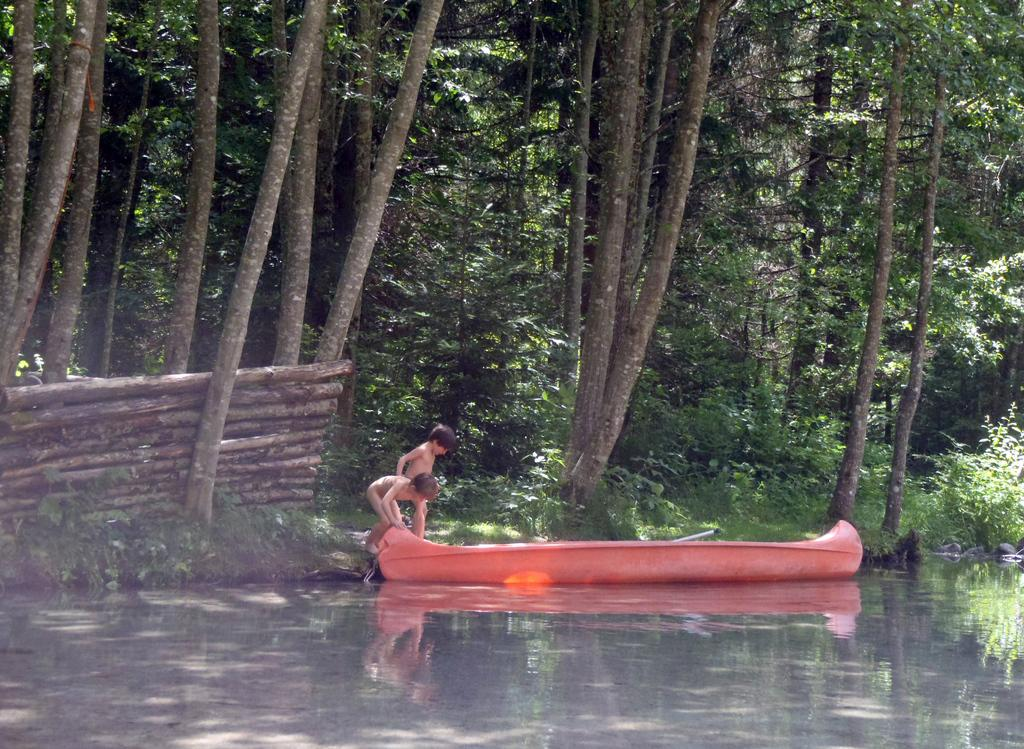What is the main subject in the foreground of the image? There is a boat in the foreground of the image. Where is the boat located? The boat is on the water. Who is present near the boat? There are two boys standing beside the boat. What can be seen in the background of the image? In the background, there are sticks, trees, plants, and grass. Can you tell me how many dinosaurs are visible in the image? There are no dinosaurs present in the image. What type of shoes are the boys wearing in the image? The provided facts do not mention the boys' shoes or feet, so we cannot determine their footwear from the image. 